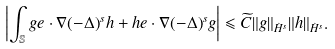Convert formula to latex. <formula><loc_0><loc_0><loc_500><loc_500>\left | \int _ { \mathbb { S } } g e \cdot \nabla ( - \Delta ) ^ { s } h + h e \cdot \nabla ( - \Delta ) ^ { s } g \right | \leqslant \widetilde { C } \| g \| _ { \dot { H } ^ { s } } \| h \| _ { \dot { H } ^ { s } } .</formula> 